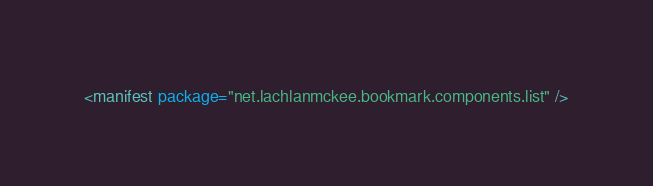Convert code to text. <code><loc_0><loc_0><loc_500><loc_500><_XML_><manifest package="net.lachlanmckee.bookmark.components.list" />
</code> 